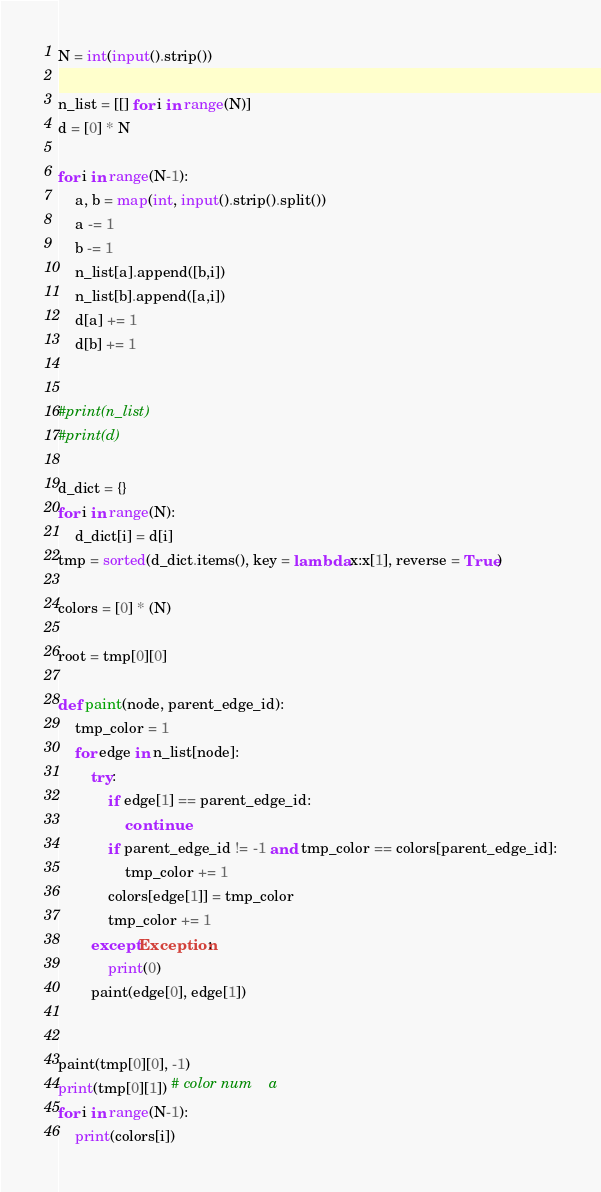<code> <loc_0><loc_0><loc_500><loc_500><_Python_>N = int(input().strip())

n_list = [[] for i in range(N)]
d = [0] * N

for i in range(N-1):
    a, b = map(int, input().strip().split())
    a -= 1
    b -= 1
    n_list[a].append([b,i])
    n_list[b].append([a,i])
    d[a] += 1
    d[b] += 1


#print(n_list)
#print(d)

d_dict = {}
for i in range(N):
    d_dict[i] = d[i]
tmp = sorted(d_dict.items(), key = lambda x:x[1], reverse = True)

colors = [0] * (N)

root = tmp[0][0]

def paint(node, parent_edge_id):
    tmp_color = 1
    for edge in n_list[node]:
        try:
            if edge[1] == parent_edge_id:
                continue
            if parent_edge_id != -1 and tmp_color == colors[parent_edge_id]:
                tmp_color += 1
            colors[edge[1]] = tmp_color
            tmp_color += 1
        except Exception:
            print(0)
        paint(edge[0], edge[1])

    
paint(tmp[0][0], -1)
print(tmp[0][1]) # color num    a
for i in range(N-1):
    print(colors[i])</code> 